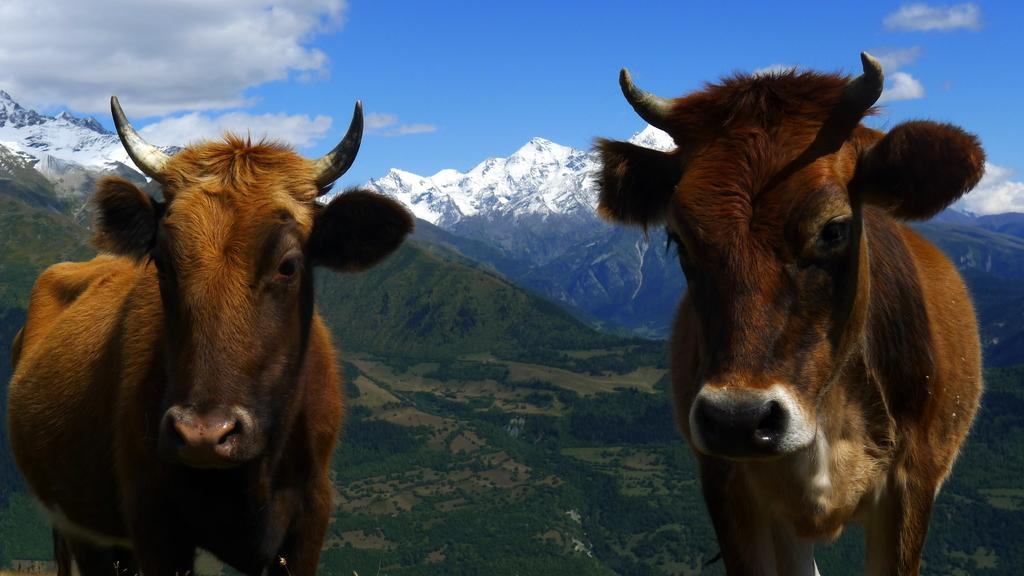What is the main subject in the center of the image? There are animals in the center of the image. What can be seen in the background of the image? There are hills and the sky visible in the background of the image. What type of force is being applied to the doll in the image? There is no doll present in the image, so the question about force cannot be answered. 